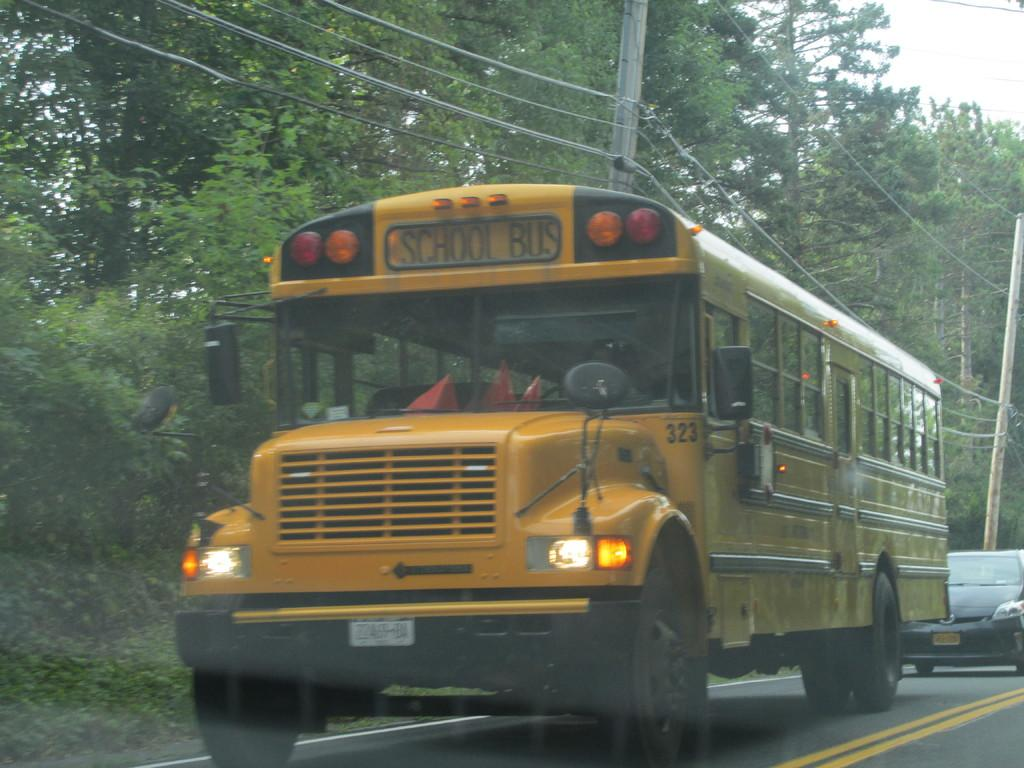Provide a one-sentence caption for the provided image. A classic American yellow schoolbus travels along a treelined road with a car not far behind it. 